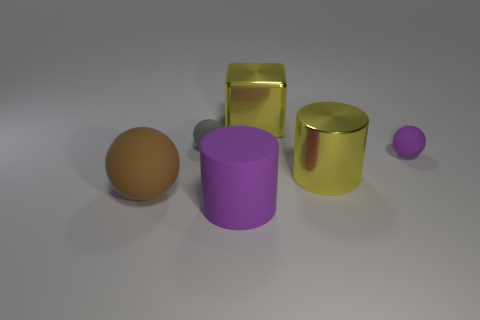How many blocks are either big green things or small objects?
Ensure brevity in your answer.  0. What color is the tiny rubber thing that is to the left of the yellow cube?
Ensure brevity in your answer.  Gray. How many metal objects are either cylinders or big balls?
Your answer should be very brief. 1. What is the material of the tiny sphere on the left side of the large purple rubber cylinder that is to the left of the tiny purple matte ball?
Offer a terse response. Rubber. What is the material of the cylinder that is the same color as the big shiny cube?
Offer a terse response. Metal. The large block is what color?
Provide a succinct answer. Yellow. There is a small thing in front of the tiny gray rubber ball; are there any large shiny things in front of it?
Your answer should be compact. Yes. What is the material of the tiny gray object?
Ensure brevity in your answer.  Rubber. Do the yellow object that is in front of the small purple ball and the tiny object that is on the left side of the big yellow metallic cylinder have the same material?
Offer a very short reply. No. Is there anything else of the same color as the large matte cylinder?
Offer a very short reply. Yes. 